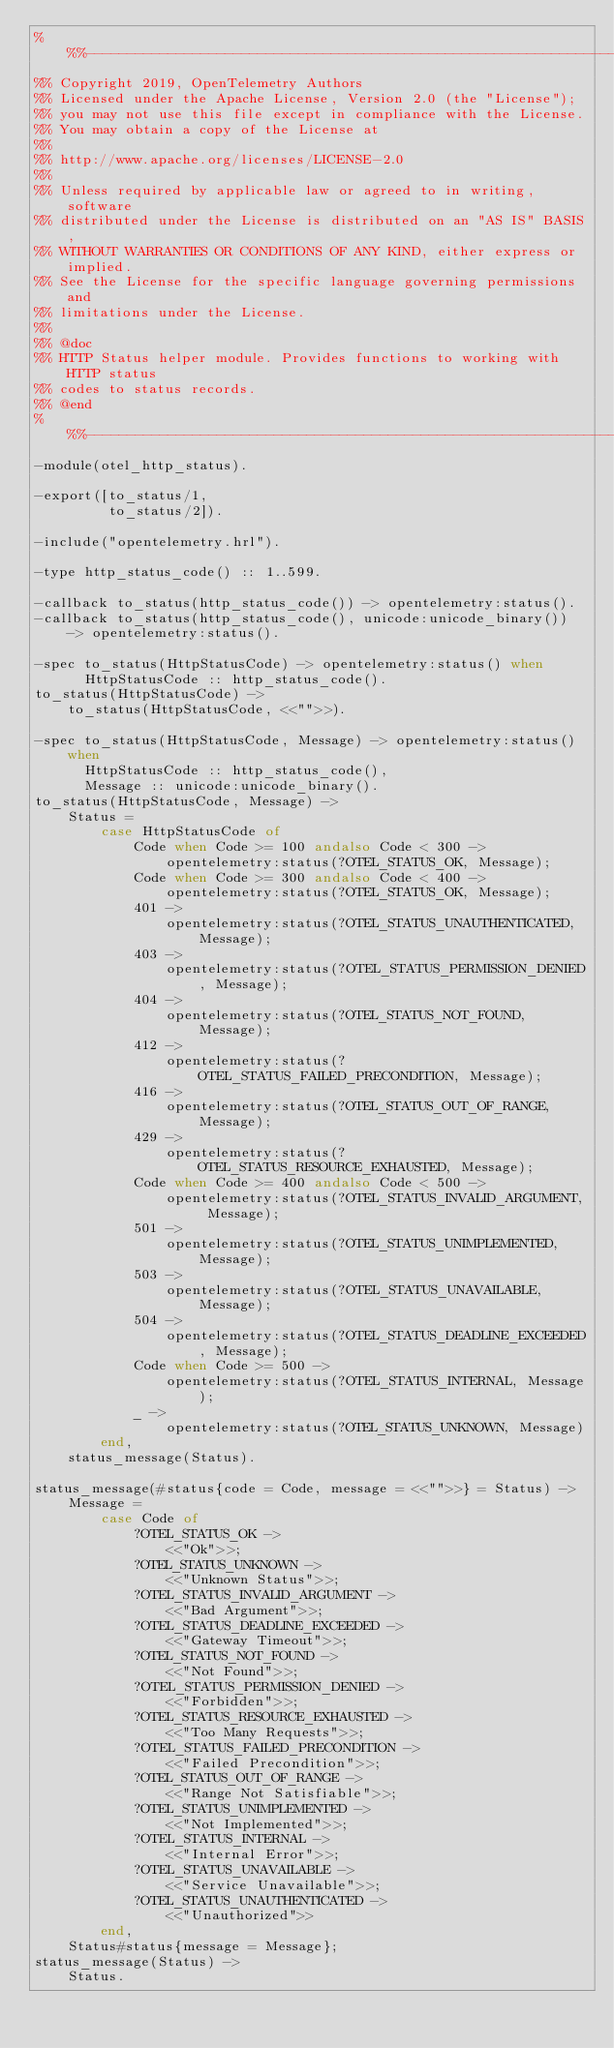<code> <loc_0><loc_0><loc_500><loc_500><_Erlang_>%%%------------------------------------------------------------------------
%% Copyright 2019, OpenTelemetry Authors
%% Licensed under the Apache License, Version 2.0 (the "License");
%% you may not use this file except in compliance with the License.
%% You may obtain a copy of the License at
%%
%% http://www.apache.org/licenses/LICENSE-2.0
%%
%% Unless required by applicable law or agreed to in writing, software
%% distributed under the License is distributed on an "AS IS" BASIS,
%% WITHOUT WARRANTIES OR CONDITIONS OF ANY KIND, either express or implied.
%% See the License for the specific language governing permissions and
%% limitations under the License.
%%
%% @doc
%% HTTP Status helper module. Provides functions to working with HTTP status
%% codes to status records.
%% @end
%%%-------------------------------------------------------------------------
-module(otel_http_status).

-export([to_status/1,
         to_status/2]).

-include("opentelemetry.hrl").

-type http_status_code() :: 1..599.

-callback to_status(http_status_code()) -> opentelemetry:status().
-callback to_status(http_status_code(), unicode:unicode_binary()) -> opentelemetry:status().

-spec to_status(HttpStatusCode) -> opentelemetry:status() when
      HttpStatusCode :: http_status_code().
to_status(HttpStatusCode) ->
    to_status(HttpStatusCode, <<"">>).

-spec to_status(HttpStatusCode, Message) -> opentelemetry:status() when
      HttpStatusCode :: http_status_code(),
      Message :: unicode:unicode_binary().
to_status(HttpStatusCode, Message) ->
    Status =
        case HttpStatusCode of
            Code when Code >= 100 andalso Code < 300 ->
                opentelemetry:status(?OTEL_STATUS_OK, Message);
            Code when Code >= 300 andalso Code < 400 ->
                opentelemetry:status(?OTEL_STATUS_OK, Message);
            401 ->
                opentelemetry:status(?OTEL_STATUS_UNAUTHENTICATED, Message);
            403 ->
                opentelemetry:status(?OTEL_STATUS_PERMISSION_DENIED, Message);
            404 ->
                opentelemetry:status(?OTEL_STATUS_NOT_FOUND, Message);
            412 ->
                opentelemetry:status(?OTEL_STATUS_FAILED_PRECONDITION, Message);
            416 ->
                opentelemetry:status(?OTEL_STATUS_OUT_OF_RANGE, Message);
            429 ->
                opentelemetry:status(?OTEL_STATUS_RESOURCE_EXHAUSTED, Message);
            Code when Code >= 400 andalso Code < 500 ->
                opentelemetry:status(?OTEL_STATUS_INVALID_ARGUMENT, Message);
            501 ->
                opentelemetry:status(?OTEL_STATUS_UNIMPLEMENTED, Message);
            503 ->
                opentelemetry:status(?OTEL_STATUS_UNAVAILABLE, Message);
            504 ->
                opentelemetry:status(?OTEL_STATUS_DEADLINE_EXCEEDED, Message);
            Code when Code >= 500 ->
                opentelemetry:status(?OTEL_STATUS_INTERNAL, Message);
            _ ->
                opentelemetry:status(?OTEL_STATUS_UNKNOWN, Message)
        end,
    status_message(Status).

status_message(#status{code = Code, message = <<"">>} = Status) ->
    Message =
        case Code of
            ?OTEL_STATUS_OK ->
                <<"Ok">>;
            ?OTEL_STATUS_UNKNOWN ->
                <<"Unknown Status">>;
            ?OTEL_STATUS_INVALID_ARGUMENT ->
                <<"Bad Argument">>;
            ?OTEL_STATUS_DEADLINE_EXCEEDED ->
                <<"Gateway Timeout">>;
            ?OTEL_STATUS_NOT_FOUND ->
                <<"Not Found">>;
            ?OTEL_STATUS_PERMISSION_DENIED ->
                <<"Forbidden">>;
            ?OTEL_STATUS_RESOURCE_EXHAUSTED ->
                <<"Too Many Requests">>;
            ?OTEL_STATUS_FAILED_PRECONDITION ->
                <<"Failed Precondition">>;
            ?OTEL_STATUS_OUT_OF_RANGE ->
                <<"Range Not Satisfiable">>;
            ?OTEL_STATUS_UNIMPLEMENTED ->
                <<"Not Implemented">>;
            ?OTEL_STATUS_INTERNAL ->
                <<"Internal Error">>;
            ?OTEL_STATUS_UNAVAILABLE ->
                <<"Service Unavailable">>;
            ?OTEL_STATUS_UNAUTHENTICATED ->
                <<"Unauthorized">>
        end,
    Status#status{message = Message};
status_message(Status) ->
    Status.
</code> 